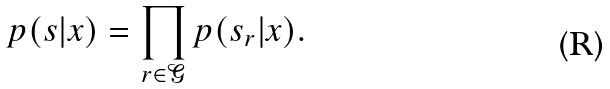Convert formula to latex. <formula><loc_0><loc_0><loc_500><loc_500>p ( s | x ) = \prod _ { r \in \mathcal { G } } p ( s _ { r } | x ) .</formula> 